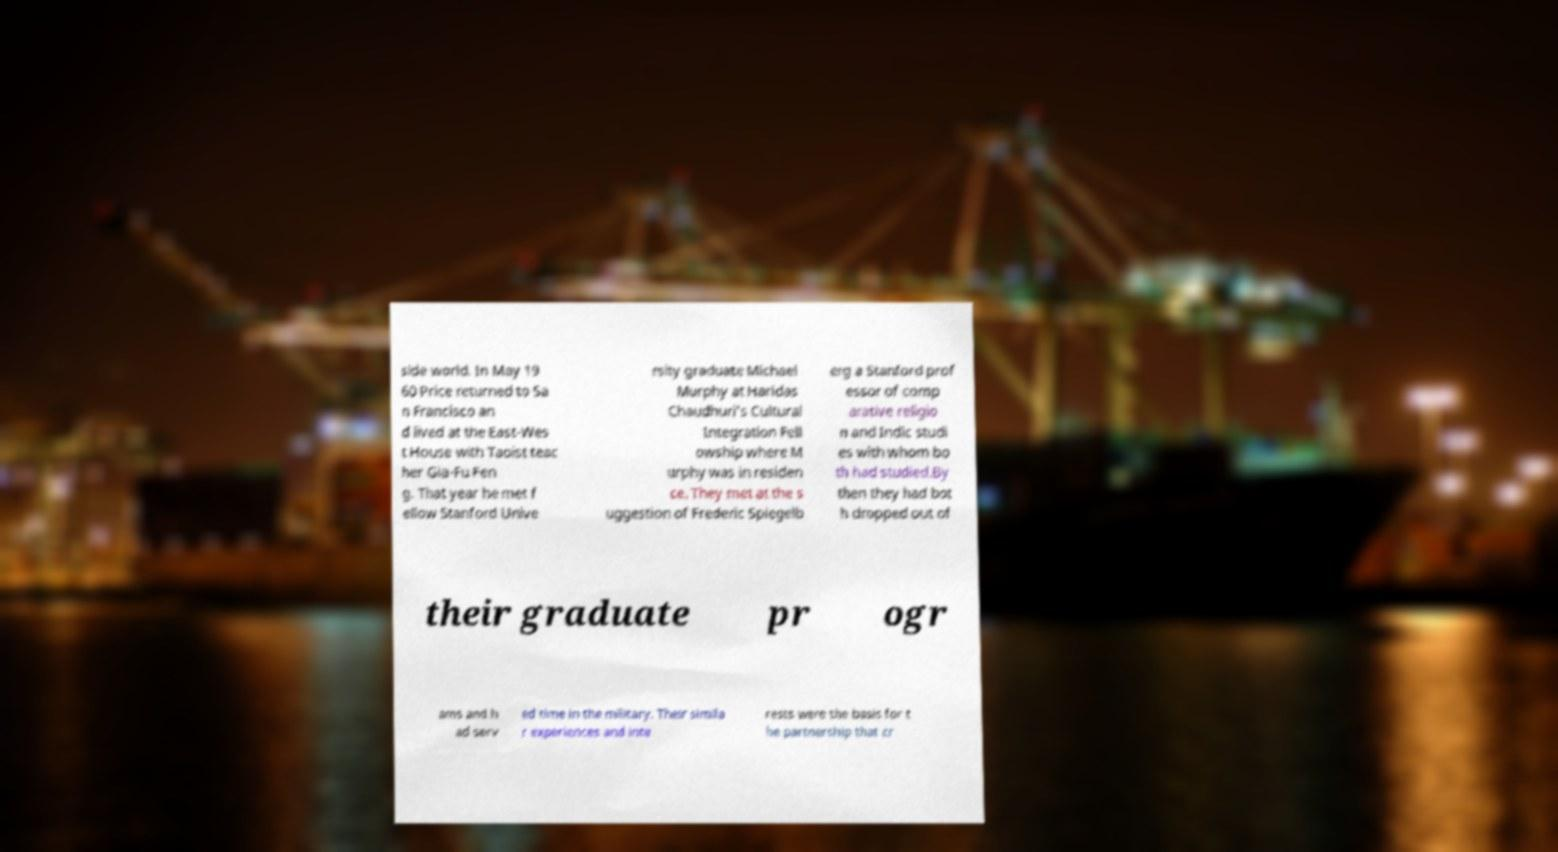I need the written content from this picture converted into text. Can you do that? side world. In May 19 60 Price returned to Sa n Francisco an d lived at the East-Wes t House with Taoist teac her Gia-Fu Fen g. That year he met f ellow Stanford Unive rsity graduate Michael Murphy at Haridas Chaudhuri’s Cultural Integration Fell owship where M urphy was in residen ce. They met at the s uggestion of Frederic Spiegelb erg a Stanford prof essor of comp arative religio n and Indic studi es with whom bo th had studied.By then they had bot h dropped out of their graduate pr ogr ams and h ad serv ed time in the military. Their simila r experiences and inte rests were the basis for t he partnership that cr 